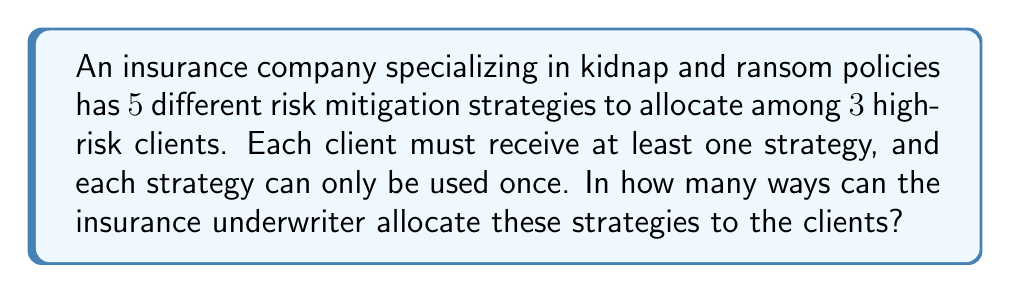Can you answer this question? Let's approach this step-by-step using the stars and bars method:

1) We have 5 strategies (objects) to distribute among 3 clients (boxes).

2) Each client must receive at least one strategy, so we start by giving one strategy to each client. This leaves us with 2 strategies to distribute.

3) Now, we need to find the number of ways to distribute 2 indistinguishable objects (remaining strategies) into 3 distinguishable boxes (clients).

4) The stars and bars formula for this scenario is:

   $$\binom{n+k-1}{k-1}$$

   where $n$ is the number of objects and $k$ is the number of boxes.

5) In our case, $n = 2$ and $k = 3$. So we calculate:

   $$\binom{2+3-1}{3-1} = \binom{4}{2}$$

6) We can calculate this combination:

   $$\binom{4}{2} = \frac{4!}{2!(4-2)!} = \frac{4 \cdot 3}{2 \cdot 1} = 6$$

7) However, this only accounts for the distribution of the remaining 2 strategies. We need to multiply this by the number of ways to arrange the initial 3 strategies among the 3 clients, which is simply $3! = 6$.

8) Therefore, the total number of ways to allocate the strategies is:

   $$6 \cdot 6 = 36$$
Answer: 36 